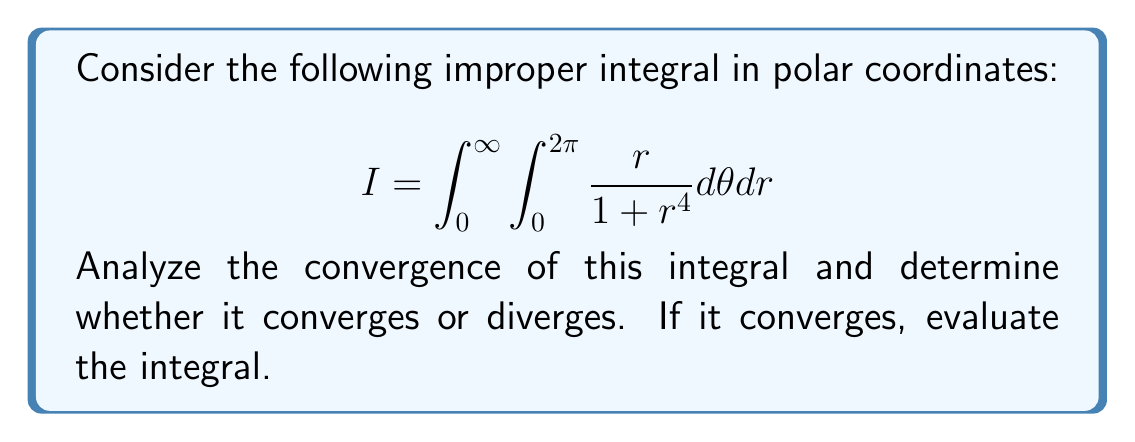Can you answer this question? Let's approach this step-by-step:

1) First, we note that the integrand is independent of $\theta$. This allows us to simplify the integral:

   $$I = \int_0^{2\pi} d\theta \int_0^{\infty} \frac{r}{1 + r^4} dr = 2\pi \int_0^{\infty} \frac{r}{1 + r^4} dr$$

2) Now we focus on the improper integral $\int_0^{\infty} \frac{r}{1 + r^4} dr$. To analyze its convergence, we'll use the comparison test.

3) For large $r$, we can compare our integrand with $\frac{1}{r^3}$:

   $$\frac{r}{1 + r^4} < \frac{r}{r^4} = \frac{1}{r^3} \text{ for } r > 1$$

4) We know that $\int_1^{\infty} \frac{1}{r^3} dr$ converges (it equals $\frac{1}{2}$). By the comparison test, our integral must also converge.

5) Now that we've established convergence, let's evaluate the integral:

   $$I = 2\pi \int_0^{\infty} \frac{r}{1 + r^4} dr$$

6) We can solve this using the substitution $u = r^2$, $du = 2r dr$:

   $$I = 2\pi \int_0^{\infty} \frac{1}{2(1 + u^2)} du = \pi \int_0^{\infty} \frac{1}{1 + u^2} du$$

7) This is a standard integral. We recognize it as the arctangent function:

   $$I = \pi [\arctan(u)]_0^{\infty} = \pi [\frac{\pi}{2} - 0] = \frac{\pi^2}{2}$$

Therefore, the integral converges and its value is $\frac{\pi^2}{2}$.
Answer: Converges; $\frac{\pi^2}{2}$ 